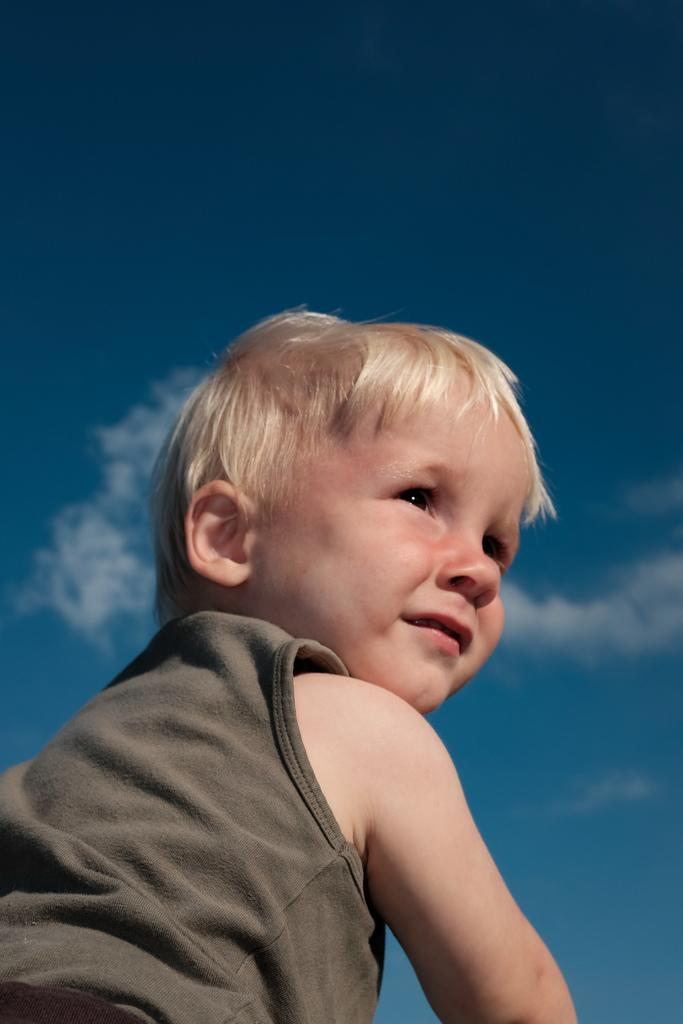What is the main subject in the center of the image? There is a boy in the center of the image. What can be seen in the background of the image? There are clouds in the sky in the background of the image. What type of yak is present in the image? There is no yak present in the image; it only features a boy and clouds in the sky. 